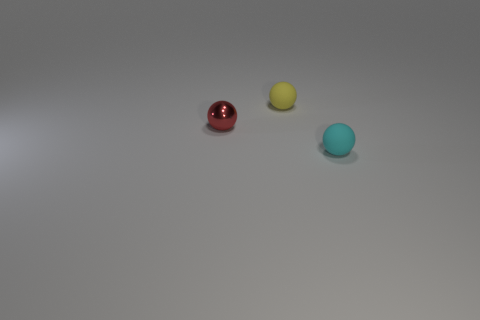Add 2 cyan rubber things. How many objects exist? 5 Subtract 0 purple cylinders. How many objects are left? 3 Subtract all spheres. Subtract all small blue balls. How many objects are left? 0 Add 1 small yellow rubber spheres. How many small yellow rubber spheres are left? 2 Add 1 red metal things. How many red metal things exist? 2 